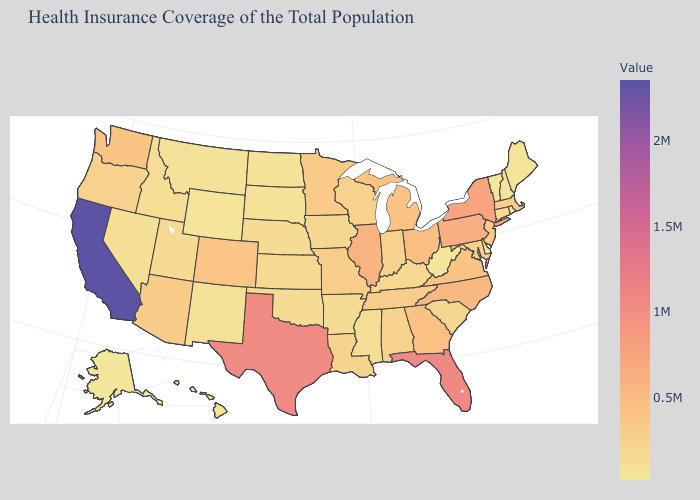Which states have the lowest value in the South?
Answer briefly. Delaware. Among the states that border Tennessee , does North Carolina have the highest value?
Concise answer only. Yes. Does Ohio have a higher value than Alaska?
Keep it brief. Yes. 